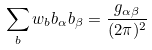<formula> <loc_0><loc_0><loc_500><loc_500>\sum _ { b } w _ { b } b _ { \alpha } b _ { \beta } = \frac { g _ { \alpha \beta } } { ( 2 \pi ) ^ { 2 } }</formula> 